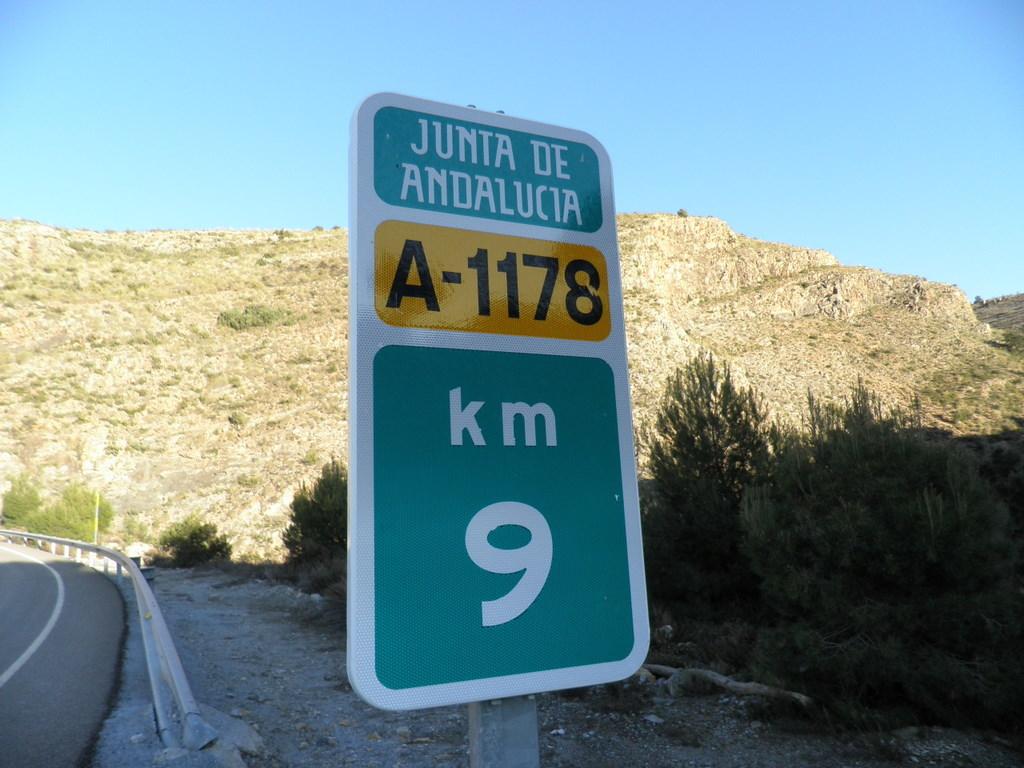How many km?
Keep it short and to the point. 9. 